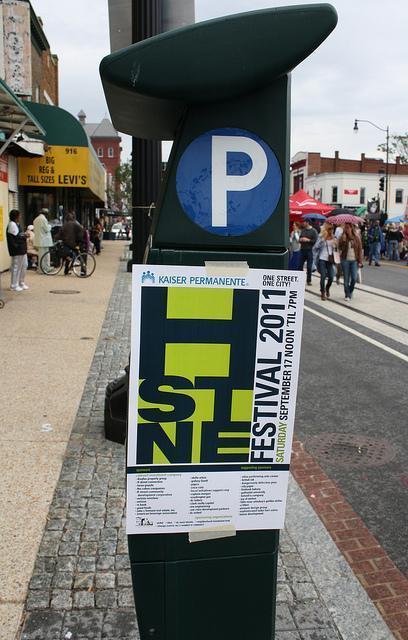How many parking meters are there?
Give a very brief answer. 1. 